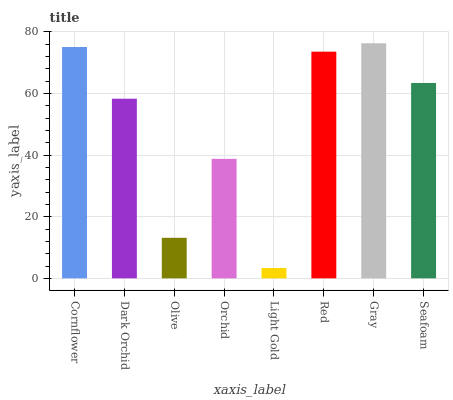Is Light Gold the minimum?
Answer yes or no. Yes. Is Gray the maximum?
Answer yes or no. Yes. Is Dark Orchid the minimum?
Answer yes or no. No. Is Dark Orchid the maximum?
Answer yes or no. No. Is Cornflower greater than Dark Orchid?
Answer yes or no. Yes. Is Dark Orchid less than Cornflower?
Answer yes or no. Yes. Is Dark Orchid greater than Cornflower?
Answer yes or no. No. Is Cornflower less than Dark Orchid?
Answer yes or no. No. Is Seafoam the high median?
Answer yes or no. Yes. Is Dark Orchid the low median?
Answer yes or no. Yes. Is Orchid the high median?
Answer yes or no. No. Is Red the low median?
Answer yes or no. No. 